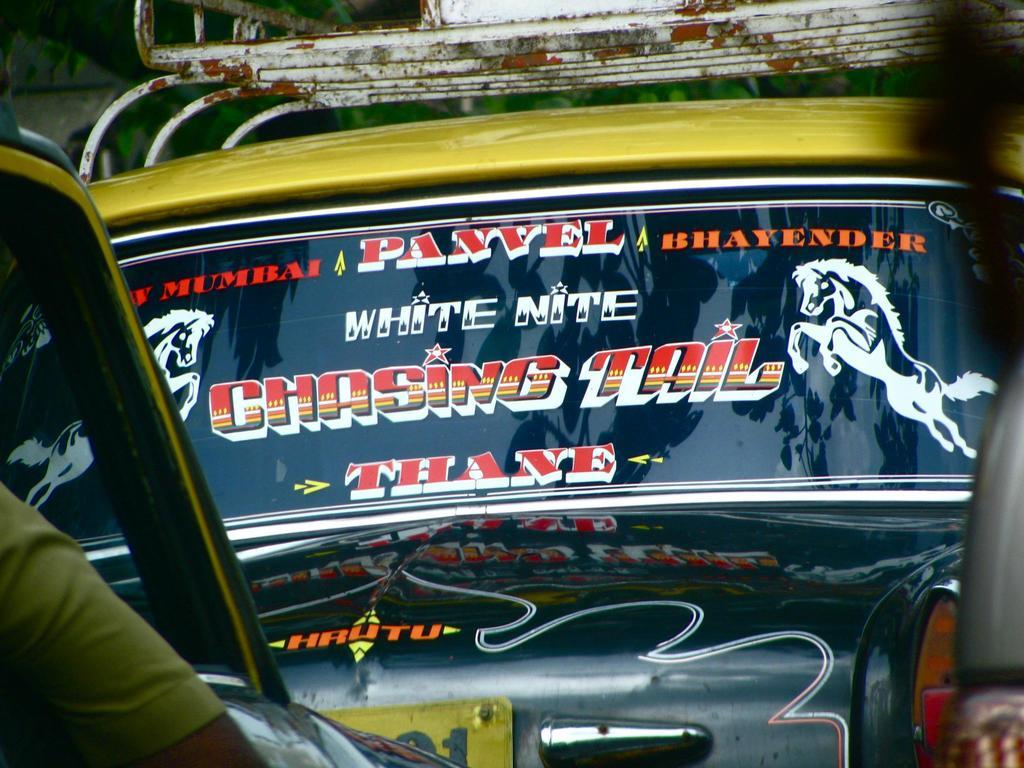What types of objects can be seen in the image? There are vehicles in the image. Can you describe any additional details about the vehicles? There are stickers attached to the glass of the vehicles. Is there any indication of a person's presence in the image? Yes, a person's hand is visible in front of the image. How many toes can be seen in the image? There are no toes visible in the image. 